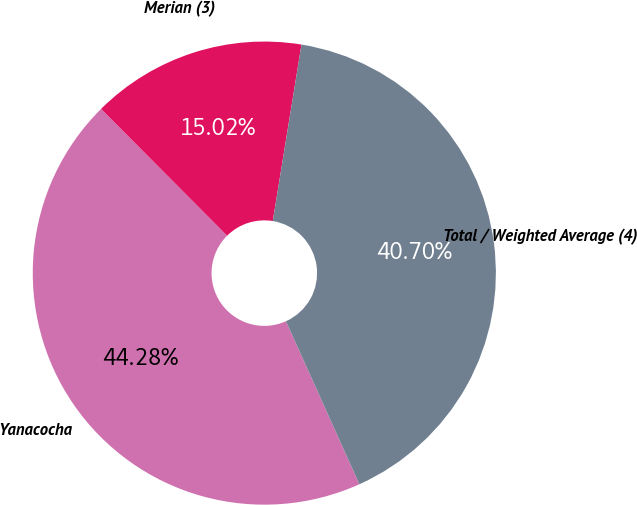Convert chart. <chart><loc_0><loc_0><loc_500><loc_500><pie_chart><fcel>Yanacocha<fcel>Merian (3)<fcel>Total / Weighted Average (4)<nl><fcel>44.28%<fcel>15.02%<fcel>40.7%<nl></chart> 